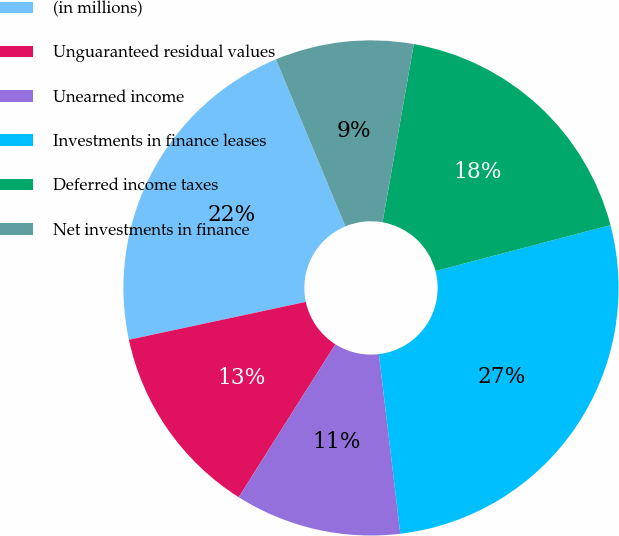<chart> <loc_0><loc_0><loc_500><loc_500><pie_chart><fcel>(in millions)<fcel>Unguaranteed residual values<fcel>Unearned income<fcel>Investments in finance leases<fcel>Deferred income taxes<fcel>Net investments in finance<nl><fcel>22.08%<fcel>12.67%<fcel>10.86%<fcel>27.19%<fcel>18.15%<fcel>9.04%<nl></chart> 